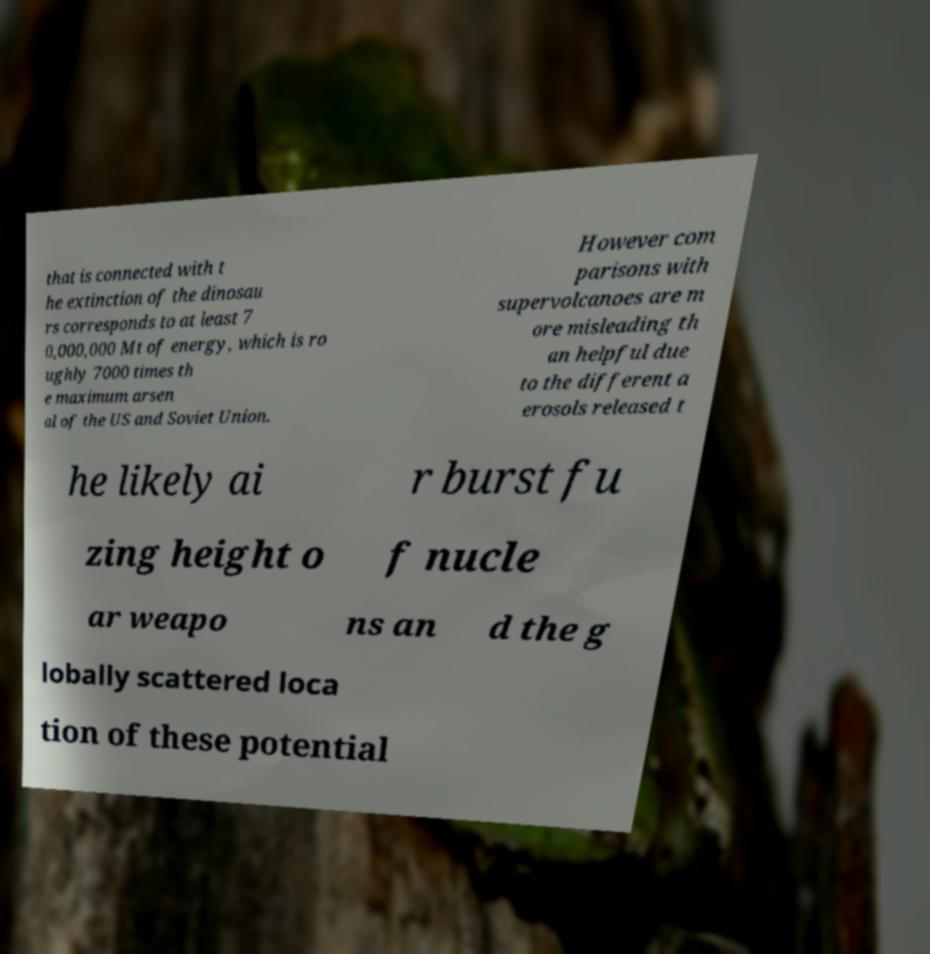Could you extract and type out the text from this image? that is connected with t he extinction of the dinosau rs corresponds to at least 7 0,000,000 Mt of energy, which is ro ughly 7000 times th e maximum arsen al of the US and Soviet Union. However com parisons with supervolcanoes are m ore misleading th an helpful due to the different a erosols released t he likely ai r burst fu zing height o f nucle ar weapo ns an d the g lobally scattered loca tion of these potential 